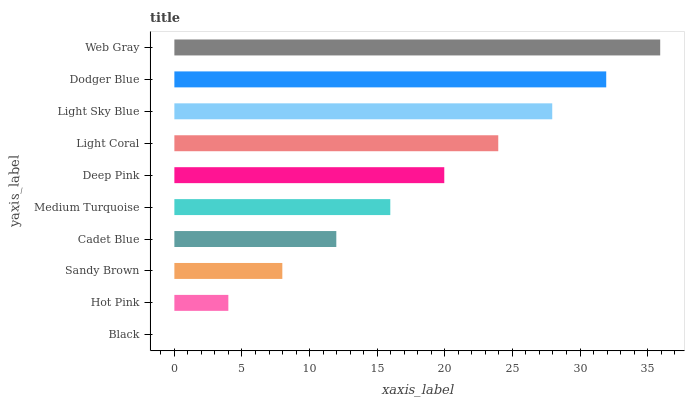Is Black the minimum?
Answer yes or no. Yes. Is Web Gray the maximum?
Answer yes or no. Yes. Is Hot Pink the minimum?
Answer yes or no. No. Is Hot Pink the maximum?
Answer yes or no. No. Is Hot Pink greater than Black?
Answer yes or no. Yes. Is Black less than Hot Pink?
Answer yes or no. Yes. Is Black greater than Hot Pink?
Answer yes or no. No. Is Hot Pink less than Black?
Answer yes or no. No. Is Deep Pink the high median?
Answer yes or no. Yes. Is Medium Turquoise the low median?
Answer yes or no. Yes. Is Cadet Blue the high median?
Answer yes or no. No. Is Deep Pink the low median?
Answer yes or no. No. 